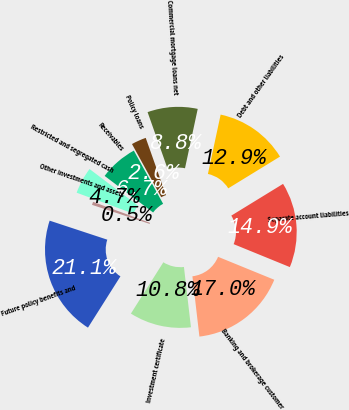Convert chart to OTSL. <chart><loc_0><loc_0><loc_500><loc_500><pie_chart><fcel>Commercial mortgage loans net<fcel>Policy loans<fcel>Receivables<fcel>Restricted and segregated cash<fcel>Other investments and assets<fcel>Future policy benefits and<fcel>Investment certificate<fcel>Banking and brokerage customer<fcel>Separate account liabilities<fcel>Debt and other liabilities<nl><fcel>8.77%<fcel>2.6%<fcel>6.71%<fcel>4.66%<fcel>0.55%<fcel>21.1%<fcel>10.82%<fcel>16.99%<fcel>14.93%<fcel>12.88%<nl></chart> 